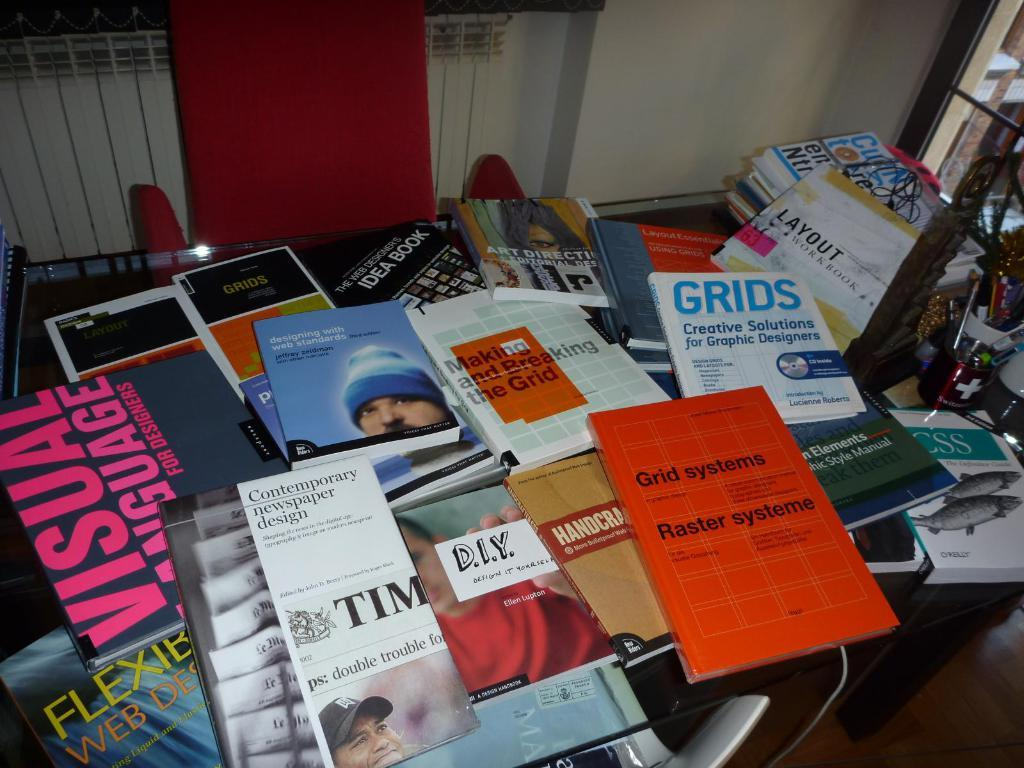Provide a one-sentence caption for the provided image. many web design and grid books and magazines are strung over the table. 